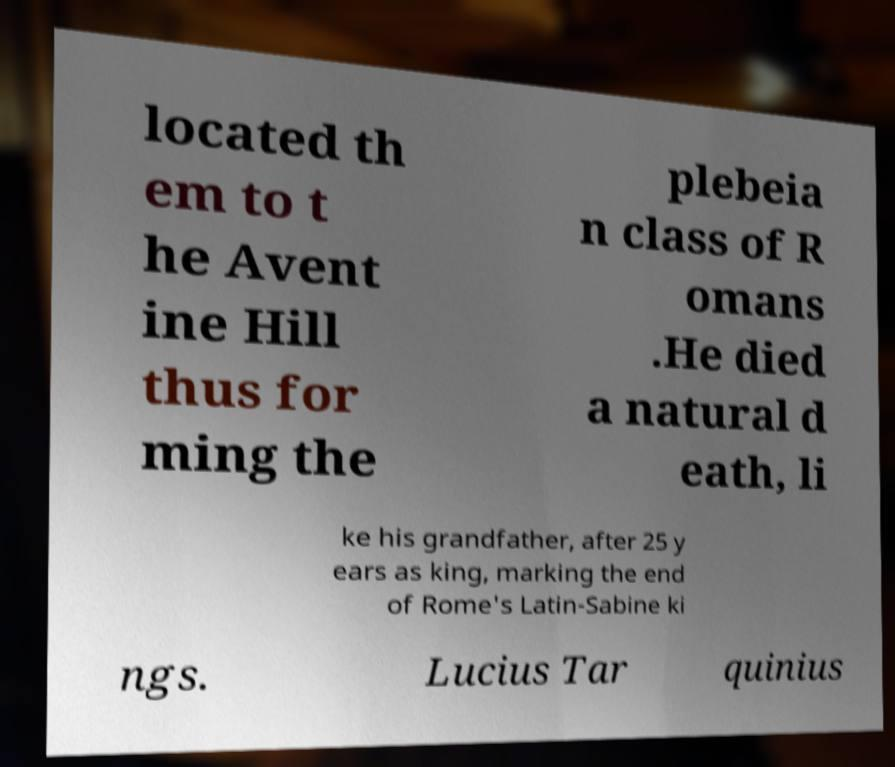Please identify and transcribe the text found in this image. located th em to t he Avent ine Hill thus for ming the plebeia n class of R omans .He died a natural d eath, li ke his grandfather, after 25 y ears as king, marking the end of Rome's Latin-Sabine ki ngs. Lucius Tar quinius 